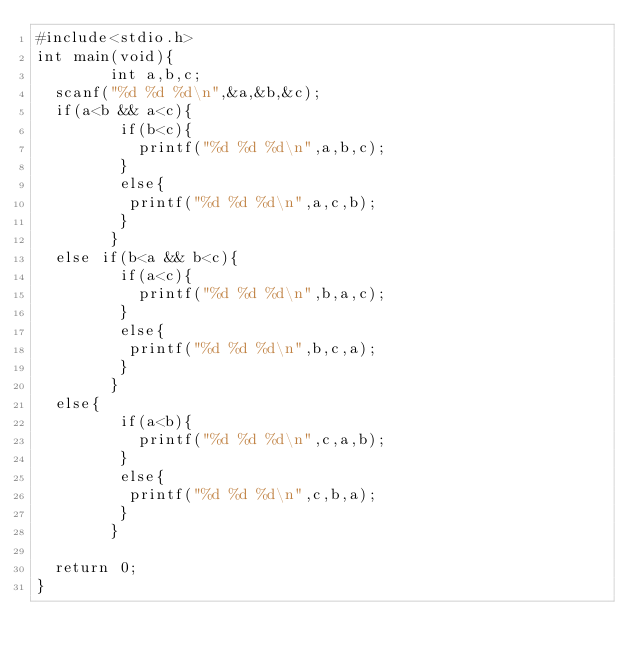<code> <loc_0><loc_0><loc_500><loc_500><_C_>#include<stdio.h>
int main(void){
        int a,b,c;
	scanf("%d %d %d\n",&a,&b,&c);
	if(a<b && a<c){
         if(b<c){
        	 printf("%d %d %d\n",a,b,c);
         }
         else{
          printf("%d %d %d\n",a,c,b);
         }
        }
	else if(b<a && b<c){
         if(a<c){
        	 printf("%d %d %d\n",b,a,c);
         }
         else{
          printf("%d %d %d\n",b,c,a);
         }
        }
	else{
         if(a<b){
        	 printf("%d %d %d\n",c,a,b);
         }
         else{
          printf("%d %d %d\n",c,b,a);
         }
        }
	
	return 0;
}</code> 